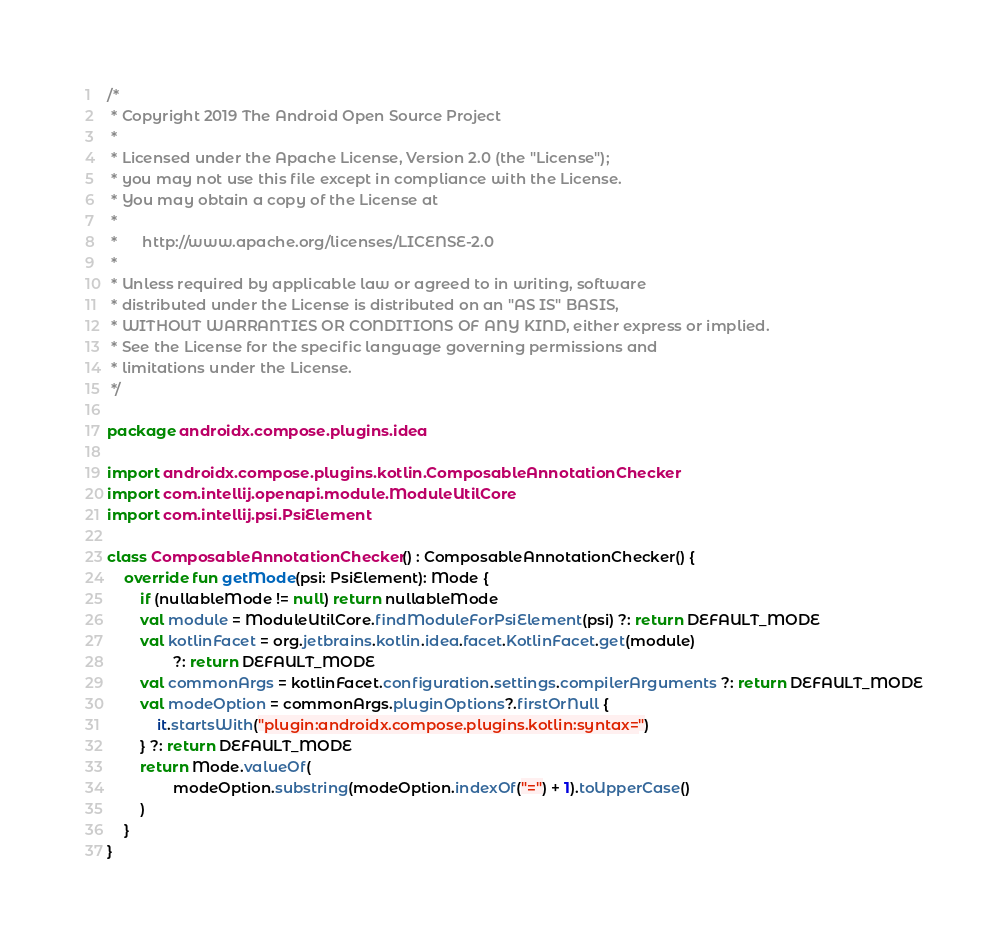<code> <loc_0><loc_0><loc_500><loc_500><_Kotlin_>/*
 * Copyright 2019 The Android Open Source Project
 *
 * Licensed under the Apache License, Version 2.0 (the "License");
 * you may not use this file except in compliance with the License.
 * You may obtain a copy of the License at
 *
 *      http://www.apache.org/licenses/LICENSE-2.0
 *
 * Unless required by applicable law or agreed to in writing, software
 * distributed under the License is distributed on an "AS IS" BASIS,
 * WITHOUT WARRANTIES OR CONDITIONS OF ANY KIND, either express or implied.
 * See the License for the specific language governing permissions and
 * limitations under the License.
 */

package androidx.compose.plugins.idea

import androidx.compose.plugins.kotlin.ComposableAnnotationChecker
import com.intellij.openapi.module.ModuleUtilCore
import com.intellij.psi.PsiElement

class ComposableAnnotationChecker() : ComposableAnnotationChecker() {
    override fun getMode(psi: PsiElement): Mode {
        if (nullableMode != null) return nullableMode
        val module = ModuleUtilCore.findModuleForPsiElement(psi) ?: return DEFAULT_MODE
        val kotlinFacet = org.jetbrains.kotlin.idea.facet.KotlinFacet.get(module)
                ?: return DEFAULT_MODE
        val commonArgs = kotlinFacet.configuration.settings.compilerArguments ?: return DEFAULT_MODE
        val modeOption = commonArgs.pluginOptions?.firstOrNull {
            it.startsWith("plugin:androidx.compose.plugins.kotlin:syntax=")
        } ?: return DEFAULT_MODE
        return Mode.valueOf(
                modeOption.substring(modeOption.indexOf("=") + 1).toUpperCase()
        )
    }
}
</code> 